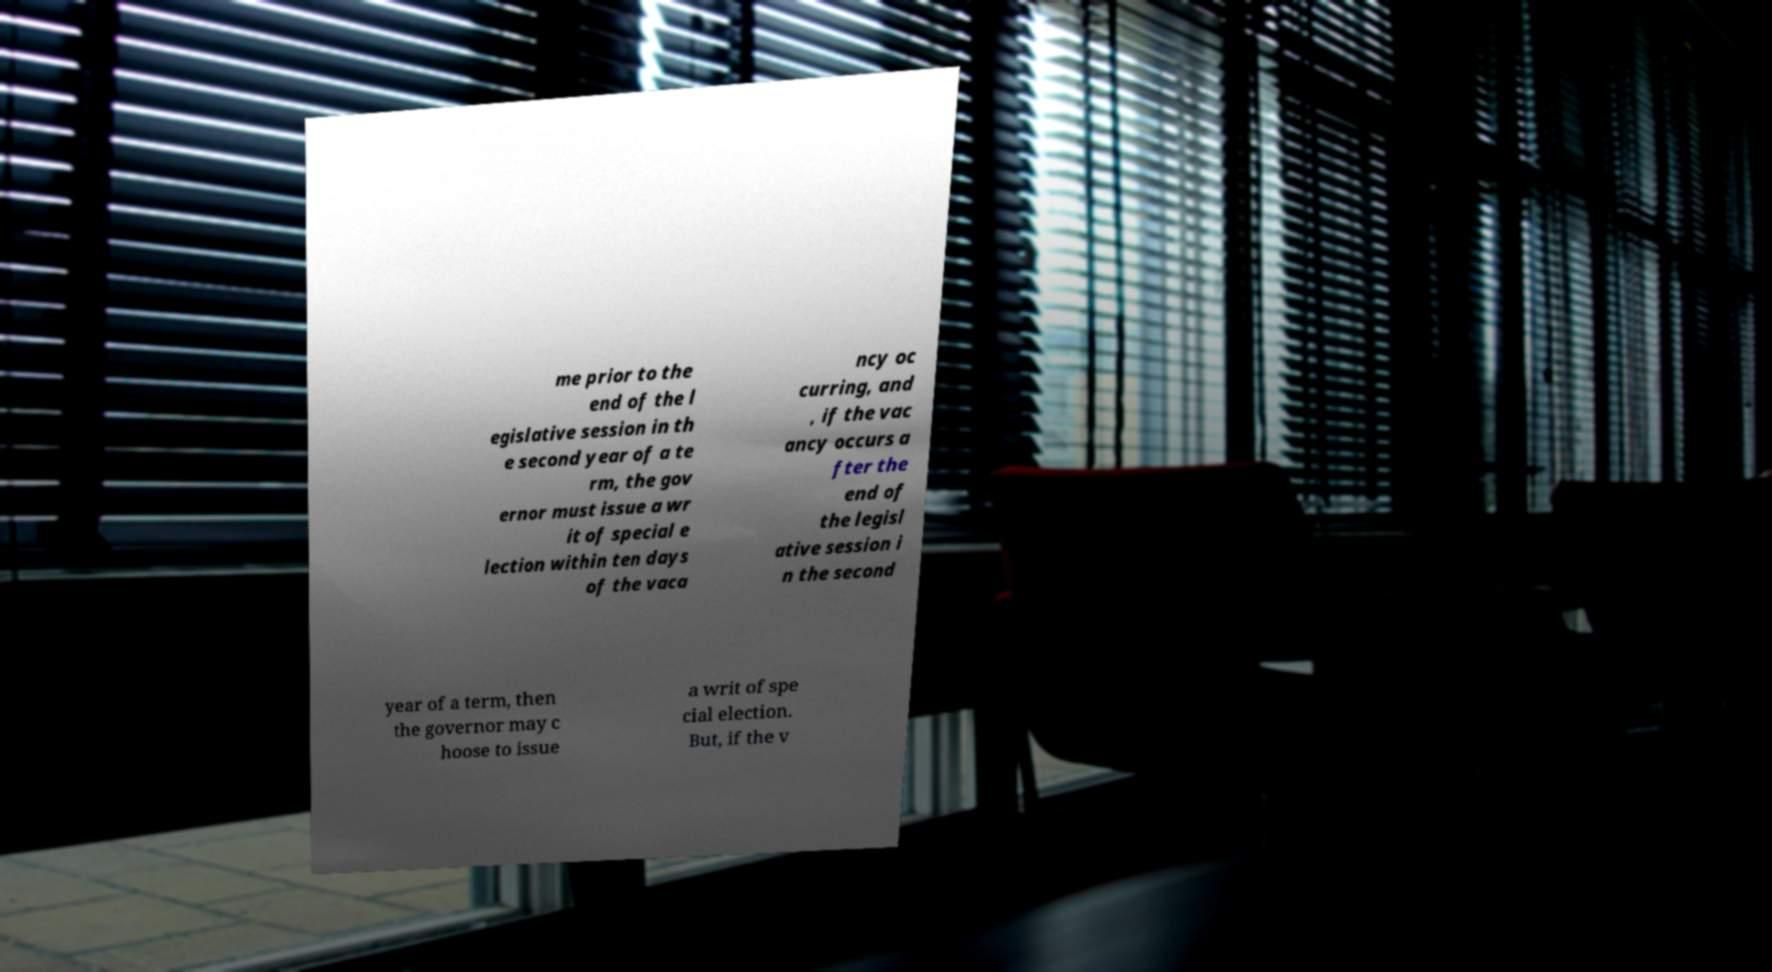Please read and relay the text visible in this image. What does it say? me prior to the end of the l egislative session in th e second year of a te rm, the gov ernor must issue a wr it of special e lection within ten days of the vaca ncy oc curring, and , if the vac ancy occurs a fter the end of the legisl ative session i n the second year of a term, then the governor may c hoose to issue a writ of spe cial election. But, if the v 